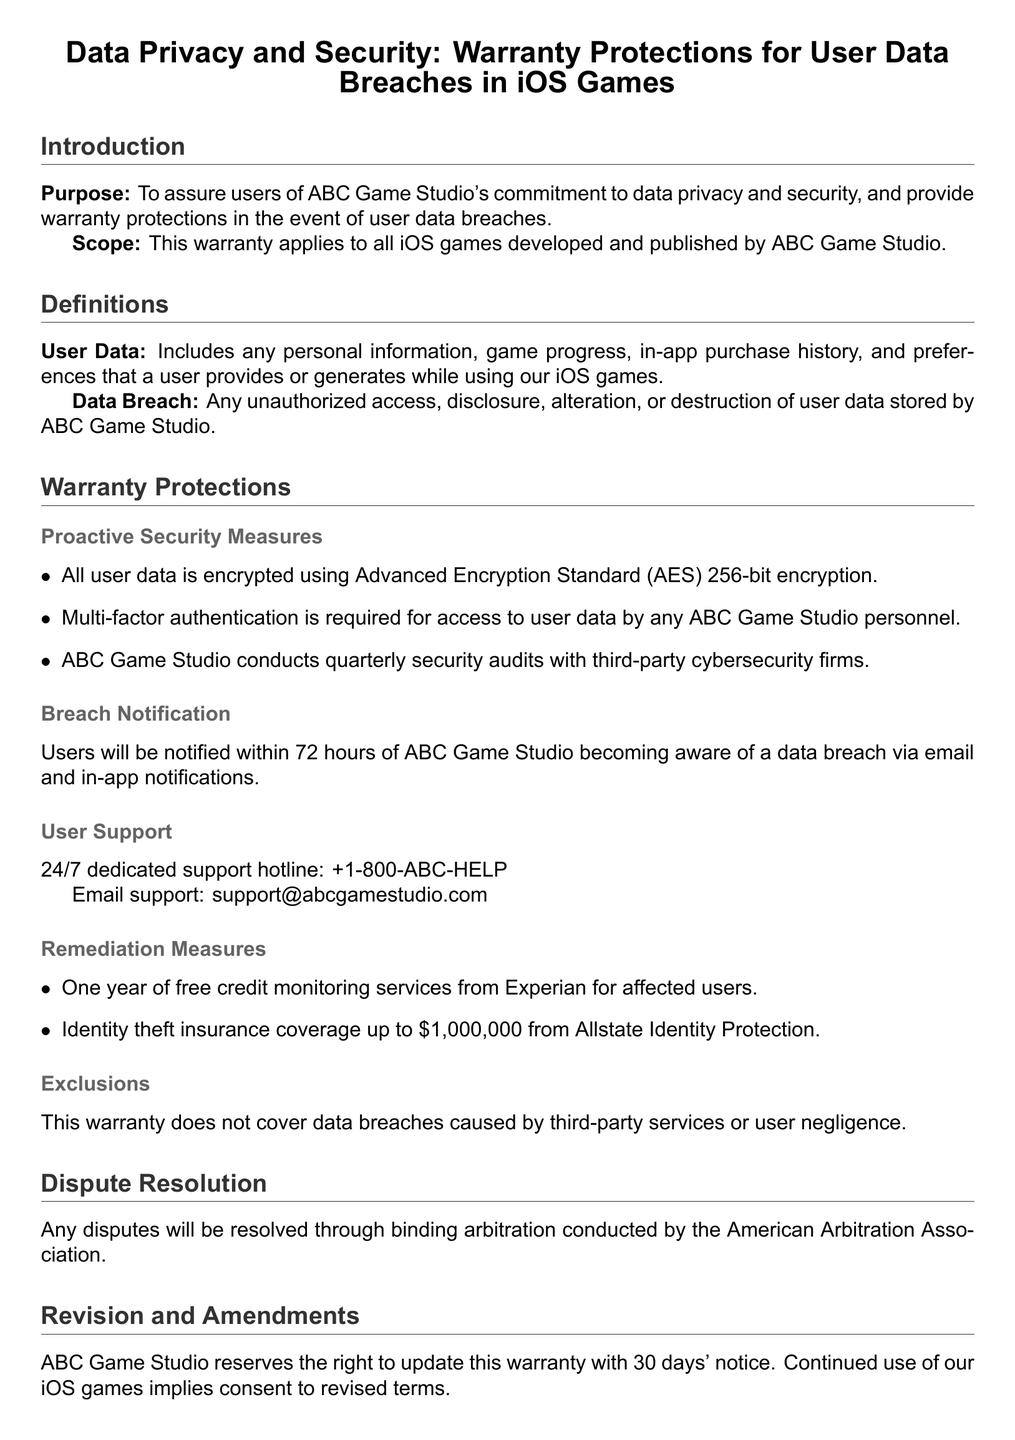what is the primary purpose of this warranty? The primary purpose of this warranty is to assure users of ABC Game Studio's commitment to data privacy and security.
Answer: commitment to data privacy and security who conducts quarterly security audits? Quarterly security audits are conducted by third-party cybersecurity firms.
Answer: third-party cybersecurity firms what encryption standard is used for user data? User data is encrypted using Advanced Encryption Standard (AES) 256-bit encryption.
Answer: AES 256-bit encryption how soon will users be notified of a data breach? Users will be notified within 72 hours of ABC Game Studio becoming aware of a data breach.
Answer: 72 hours what type of insurance is provided to affected users? Affected users receive identity theft insurance coverage.
Answer: identity theft insurance what is excluded from the warranty? The warranty does not cover data breaches caused by third-party services or user negligence.
Answer: third-party services or user negligence how long of credit monitoring services is offered? Affected users are offered one year of free credit monitoring services.
Answer: one year who can users contact for support? Users can contact a dedicated support hotline and email for assistance.
Answer: 24/7 dedicated support hotline and email what is the company address? The address of ABC Game Studio is provided in the contact information section.
Answer: 123 Silicon Valley Blvd, San Jose, CA 95123, USA 